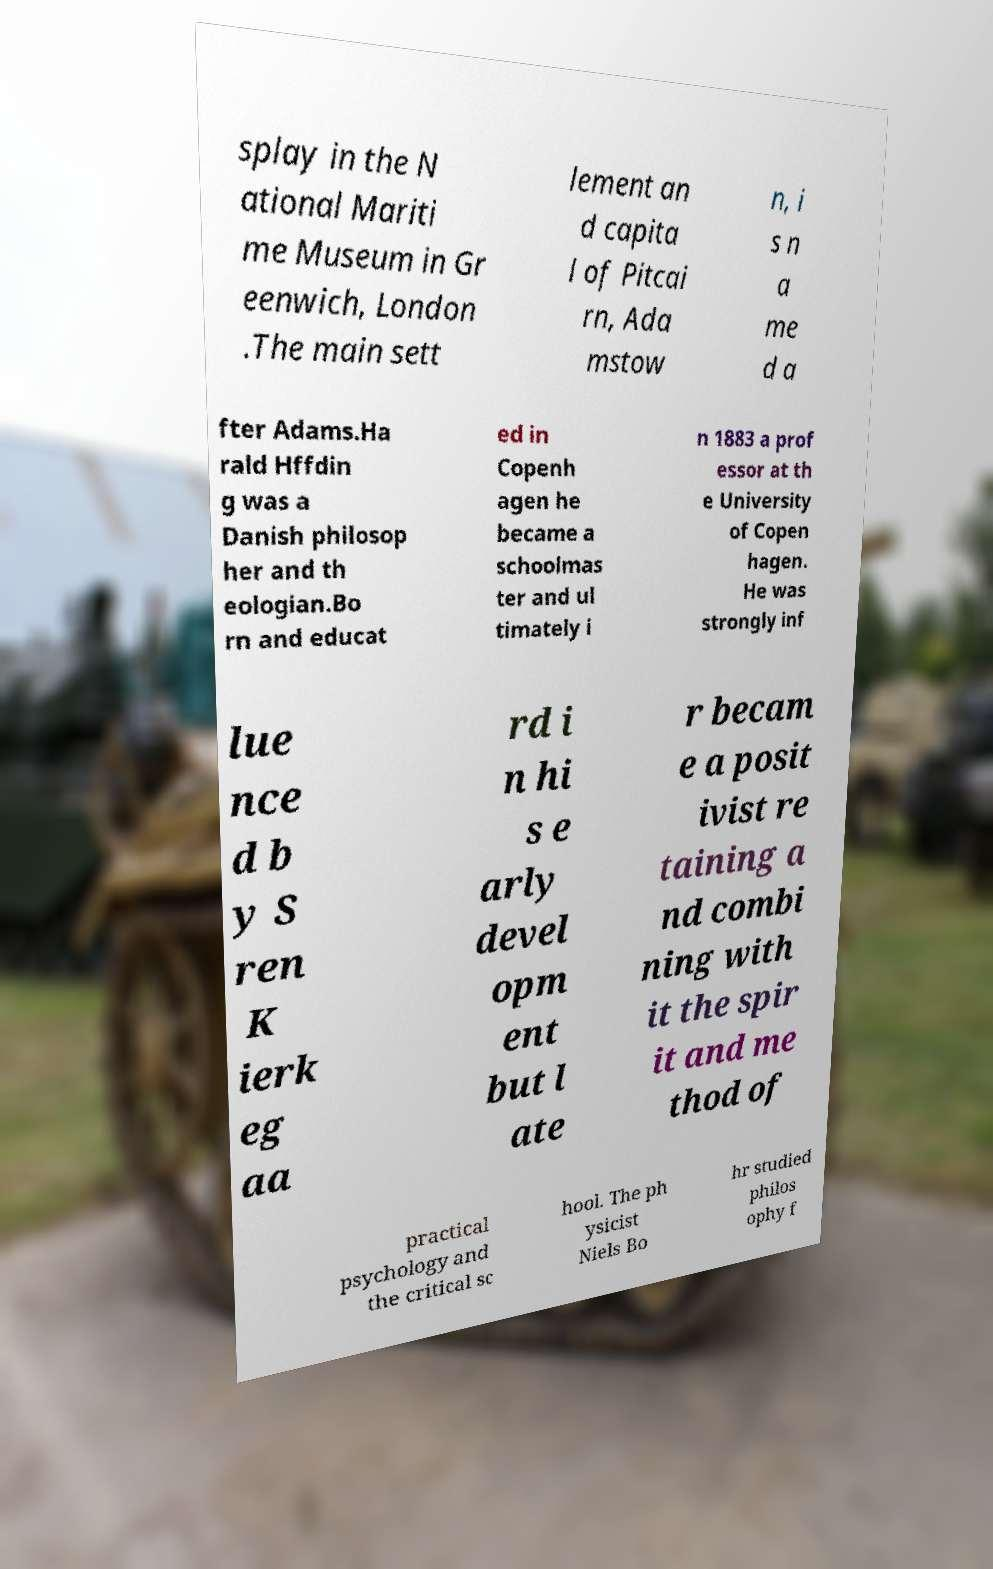Could you assist in decoding the text presented in this image and type it out clearly? splay in the N ational Mariti me Museum in Gr eenwich, London .The main sett lement an d capita l of Pitcai rn, Ada mstow n, i s n a me d a fter Adams.Ha rald Hffdin g was a Danish philosop her and th eologian.Bo rn and educat ed in Copenh agen he became a schoolmas ter and ul timately i n 1883 a prof essor at th e University of Copen hagen. He was strongly inf lue nce d b y S ren K ierk eg aa rd i n hi s e arly devel opm ent but l ate r becam e a posit ivist re taining a nd combi ning with it the spir it and me thod of practical psychology and the critical sc hool. The ph ysicist Niels Bo hr studied philos ophy f 